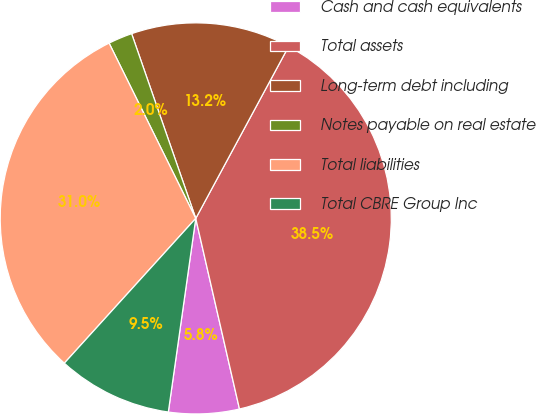Convert chart. <chart><loc_0><loc_0><loc_500><loc_500><pie_chart><fcel>Cash and cash equivalents<fcel>Total assets<fcel>Long-term debt including<fcel>Notes payable on real estate<fcel>Total liabilities<fcel>Total CBRE Group Inc<nl><fcel>5.83%<fcel>38.53%<fcel>13.2%<fcel>1.99%<fcel>30.96%<fcel>9.49%<nl></chart> 